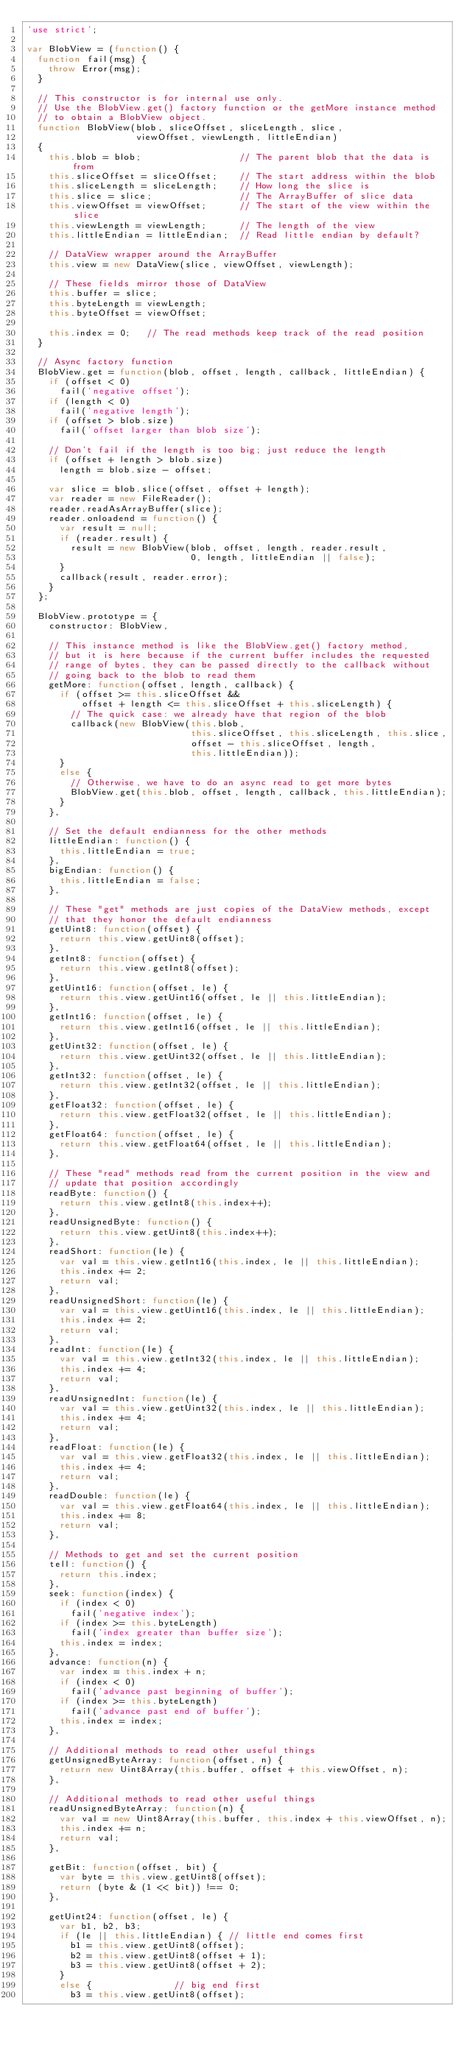Convert code to text. <code><loc_0><loc_0><loc_500><loc_500><_JavaScript_>'use strict';

var BlobView = (function() {
  function fail(msg) {
    throw Error(msg);
  }

  // This constructor is for internal use only.
  // Use the BlobView.get() factory function or the getMore instance method
  // to obtain a BlobView object.
  function BlobView(blob, sliceOffset, sliceLength, slice, 
                    viewOffset, viewLength, littleEndian)
  {
    this.blob = blob;                  // The parent blob that the data is from
    this.sliceOffset = sliceOffset;    // The start address within the blob
    this.sliceLength = sliceLength;    // How long the slice is
    this.slice = slice;                // The ArrayBuffer of slice data
    this.viewOffset = viewOffset;      // The start of the view within the slice
    this.viewLength = viewLength;      // The length of the view
    this.littleEndian = littleEndian;  // Read little endian by default?

    // DataView wrapper around the ArrayBuffer
    this.view = new DataView(slice, viewOffset, viewLength);

    // These fields mirror those of DataView
    this.buffer = slice;
    this.byteLength = viewLength;
    this.byteOffset = viewOffset;

    this.index = 0;   // The read methods keep track of the read position
  }

  // Async factory function
  BlobView.get = function(blob, offset, length, callback, littleEndian) {
    if (offset < 0)
      fail('negative offset');
    if (length < 0)
      fail('negative length');
    if (offset > blob.size)
      fail('offset larger than blob size');

    // Don't fail if the length is too big; just reduce the length
    if (offset + length > blob.size)
      length = blob.size - offset;

    var slice = blob.slice(offset, offset + length);
    var reader = new FileReader();
    reader.readAsArrayBuffer(slice);
    reader.onloadend = function() {
      var result = null;
      if (reader.result) {
        result = new BlobView(blob, offset, length, reader.result,
                              0, length, littleEndian || false);
      }
      callback(result, reader.error);
    }
  };

  BlobView.prototype = {
    constructor: BlobView,

    // This instance method is like the BlobView.get() factory method,
    // but it is here because if the current buffer includes the requested
    // range of bytes, they can be passed directly to the callback without
    // going back to the blob to read them
    getMore: function(offset, length, callback) {
      if (offset >= this.sliceOffset &&
          offset + length <= this.sliceOffset + this.sliceLength) {
        // The quick case: we already have that region of the blob
        callback(new BlobView(this.blob,
                              this.sliceOffset, this.sliceLength, this.slice,
                              offset - this.sliceOffset, length,
                              this.littleEndian));
      }
      else {
        // Otherwise, we have to do an async read to get more bytes
        BlobView.get(this.blob, offset, length, callback, this.littleEndian);
      }
    },

    // Set the default endianness for the other methods
    littleEndian: function() {
      this.littleEndian = true;
    },
    bigEndian: function() {
      this.littleEndian = false;
    },

    // These "get" methods are just copies of the DataView methods, except
    // that they honor the default endianness
    getUint8: function(offset) {
      return this.view.getUint8(offset);
    },
    getInt8: function(offset) {
      return this.view.getInt8(offset);
    },
    getUint16: function(offset, le) {
      return this.view.getUint16(offset, le || this.littleEndian);
    },
    getInt16: function(offset, le) {
      return this.view.getInt16(offset, le || this.littleEndian);
    },
    getUint32: function(offset, le) {
      return this.view.getUint32(offset, le || this.littleEndian);
    },
    getInt32: function(offset, le) {
      return this.view.getInt32(offset, le || this.littleEndian);
    },
    getFloat32: function(offset, le) {
      return this.view.getFloat32(offset, le || this.littleEndian);
    },
    getFloat64: function(offset, le) {
      return this.view.getFloat64(offset, le || this.littleEndian);
    },

    // These "read" methods read from the current position in the view and
    // update that position accordingly
    readByte: function() {
      return this.view.getInt8(this.index++);
    },
    readUnsignedByte: function() {
      return this.view.getUint8(this.index++);
    },
    readShort: function(le) {
      var val = this.view.getInt16(this.index, le || this.littleEndian);
      this.index += 2;
      return val;
    },
    readUnsignedShort: function(le) {
      var val = this.view.getUint16(this.index, le || this.littleEndian);
      this.index += 2;
      return val;
    },
    readInt: function(le) {
      var val = this.view.getInt32(this.index, le || this.littleEndian);
      this.index += 4;
      return val;
    },
    readUnsignedInt: function(le) {
      var val = this.view.getUint32(this.index, le || this.littleEndian);
      this.index += 4;
      return val;
    },
    readFloat: function(le) {
      var val = this.view.getFloat32(this.index, le || this.littleEndian);
      this.index += 4;
      return val;
    },
    readDouble: function(le) {
      var val = this.view.getFloat64(this.index, le || this.littleEndian);
      this.index += 8;
      return val;
    },

    // Methods to get and set the current position
    tell: function() {
      return this.index;
    },
    seek: function(index) {
      if (index < 0)
        fail('negative index');
      if (index >= this.byteLength)
        fail('index greater than buffer size');
      this.index = index;
    },
    advance: function(n) {
      var index = this.index + n;
      if (index < 0)
        fail('advance past beginning of buffer');
      if (index >= this.byteLength)
        fail('advance past end of buffer');
      this.index = index;
    },

    // Additional methods to read other useful things
    getUnsignedByteArray: function(offset, n) {
      return new Uint8Array(this.buffer, offset + this.viewOffset, n);
    },

    // Additional methods to read other useful things
    readUnsignedByteArray: function(n) {
      var val = new Uint8Array(this.buffer, this.index + this.viewOffset, n);
      this.index += n;
      return val;
    },

    getBit: function(offset, bit) {
      var byte = this.view.getUint8(offset);
      return (byte & (1 << bit)) !== 0;
    },

    getUint24: function(offset, le) {
      var b1, b2, b3;
      if (le || this.littleEndian) { // little end comes first
        b1 = this.view.getUint8(offset);
        b2 = this.view.getUint8(offset + 1);
        b3 = this.view.getUint8(offset + 2);
      }
      else {               // big end first
        b3 = this.view.getUint8(offset);</code> 